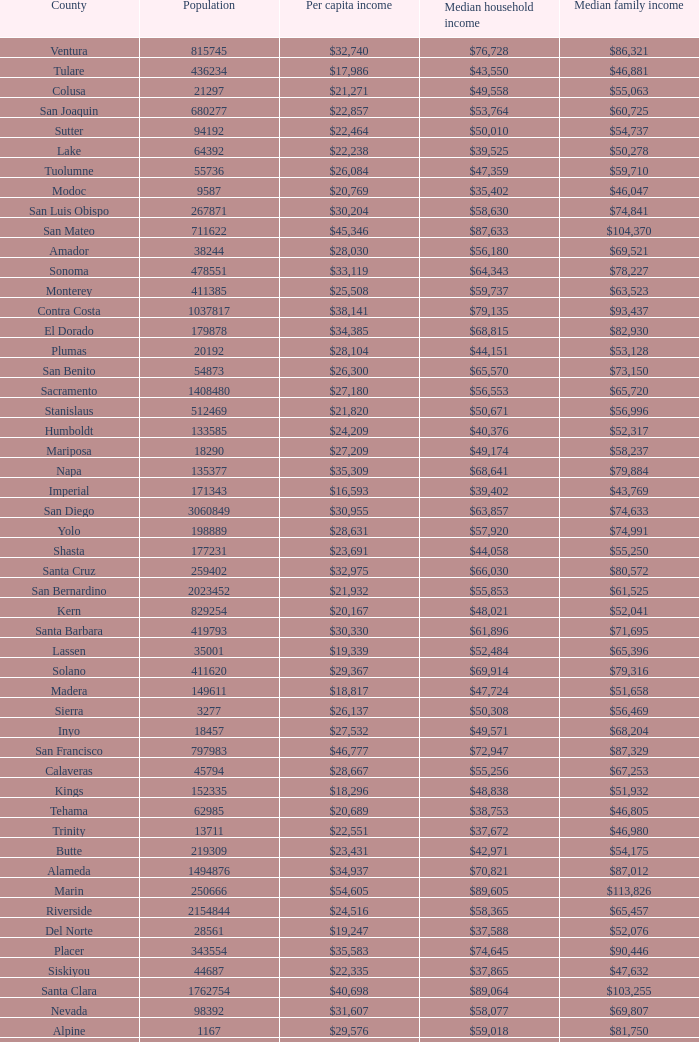What is the median household income of butte? $42,971. 